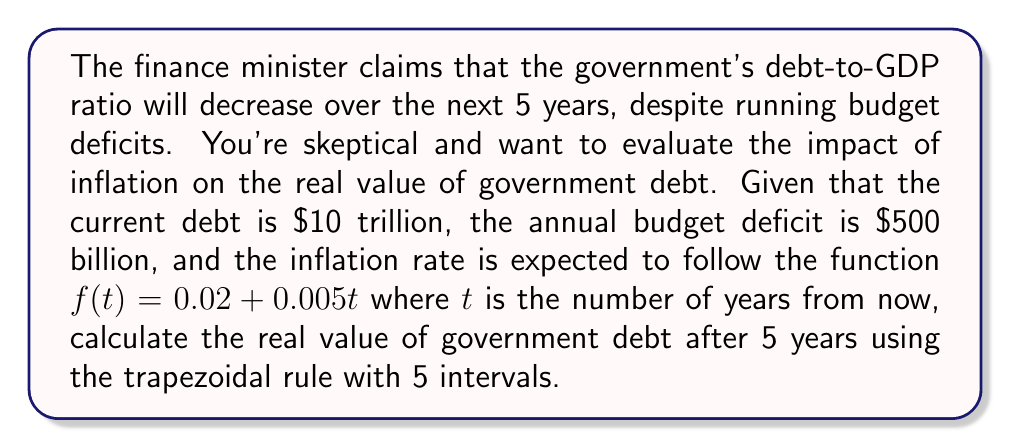Can you solve this math problem? To solve this problem, we'll follow these steps:

1) First, we need to understand that the real value of debt decreases with inflation. We'll use the continuous compound interest formula to model this:

   $D(t) = D_0 e^{-\int_0^t f(x) dx}$

   Where $D(t)$ is the real value of debt at time $t$, $D_0$ is the initial debt, and $f(x)$ is the inflation rate function.

2) We need to integrate $f(t) = 0.02 + 0.005t$ from 0 to 5:

   $\int_0^5 (0.02 + 0.005t) dt$

3) We'll use the trapezoidal rule with 5 intervals. The formula is:

   $\int_a^b f(x) dx \approx \frac{h}{2}[f(x_0) + 2f(x_1) + 2f(x_2) + ... + 2f(x_{n-1}) + f(x_n)]$

   Where $h = \frac{b-a}{n}$, $n$ is the number of intervals, and $x_i = a + ih$

4) In our case, $a=0$, $b=5$, $n=5$, so $h = 1$

5) Calculate $f(x)$ for each point:
   $f(0) = 0.02$
   $f(1) = 0.025$
   $f(2) = 0.03$
   $f(3) = 0.035$
   $f(4) = 0.04$
   $f(5) = 0.045$

6) Apply the trapezoidal rule:

   $\int_0^5 f(t) dt \approx \frac{1}{2}[0.02 + 2(0.025) + 2(0.03) + 2(0.035) + 2(0.04) + 0.045] = 0.1625$

7) Now, we can calculate the real value of the debt:

   $D(5) = (10 + 5 * 0.5) * e^{-0.1625} = 12.5 * 0.8498 = 10.62$ trillion

Therefore, the real value of government debt after 5 years is approximately $10.62 trillion.
Answer: $10.62 trillion 